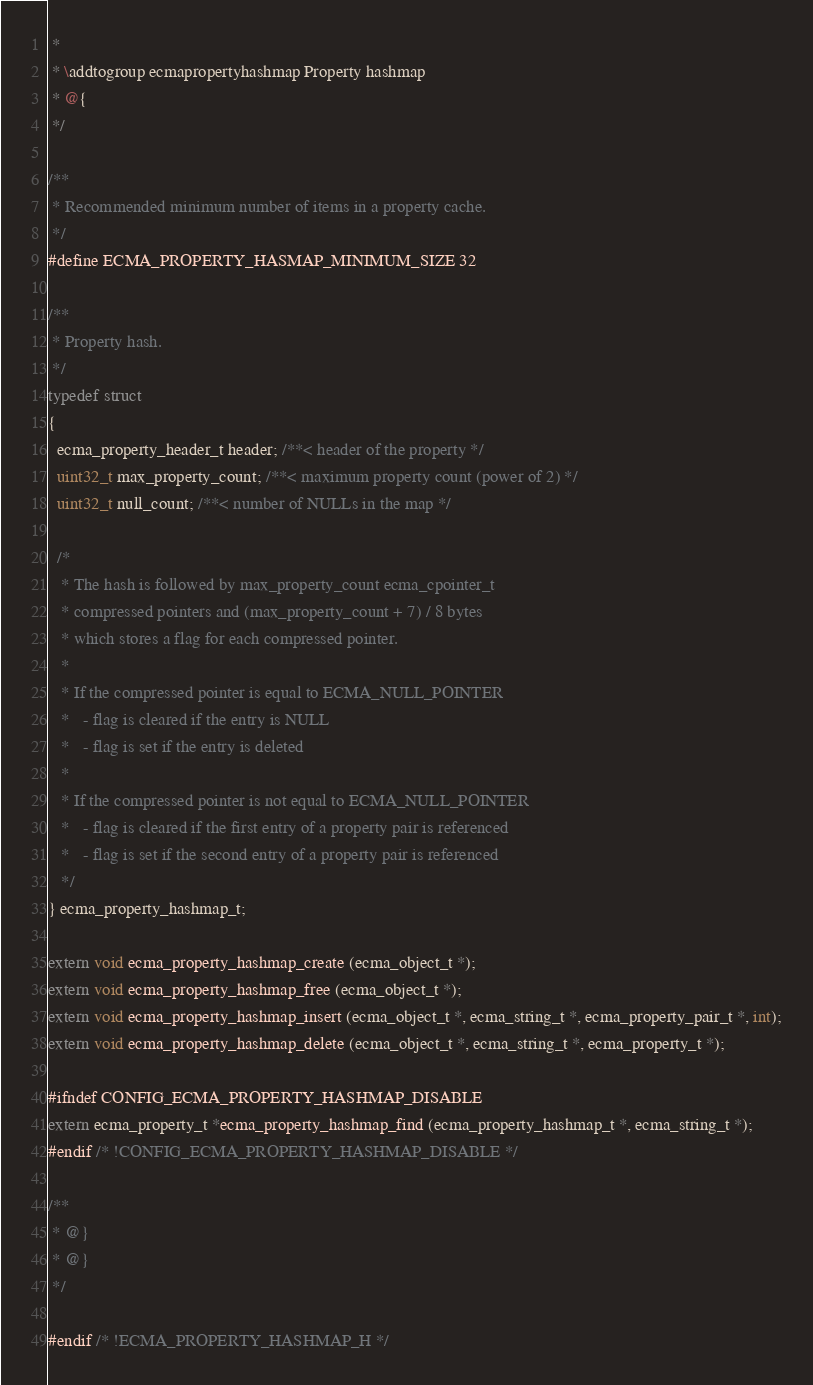<code> <loc_0><loc_0><loc_500><loc_500><_C_> *
 * \addtogroup ecmapropertyhashmap Property hashmap
 * @{
 */

/**
 * Recommended minimum number of items in a property cache.
 */
#define ECMA_PROPERTY_HASMAP_MINIMUM_SIZE 32

/**
 * Property hash.
 */
typedef struct
{
  ecma_property_header_t header; /**< header of the property */
  uint32_t max_property_count; /**< maximum property count (power of 2) */
  uint32_t null_count; /**< number of NULLs in the map */

  /*
   * The hash is followed by max_property_count ecma_cpointer_t
   * compressed pointers and (max_property_count + 7) / 8 bytes
   * which stores a flag for each compressed pointer.
   *
   * If the compressed pointer is equal to ECMA_NULL_POINTER
   *   - flag is cleared if the entry is NULL
   *   - flag is set if the entry is deleted
   *
   * If the compressed pointer is not equal to ECMA_NULL_POINTER
   *   - flag is cleared if the first entry of a property pair is referenced
   *   - flag is set if the second entry of a property pair is referenced
   */
} ecma_property_hashmap_t;

extern void ecma_property_hashmap_create (ecma_object_t *);
extern void ecma_property_hashmap_free (ecma_object_t *);
extern void ecma_property_hashmap_insert (ecma_object_t *, ecma_string_t *, ecma_property_pair_t *, int);
extern void ecma_property_hashmap_delete (ecma_object_t *, ecma_string_t *, ecma_property_t *);

#ifndef CONFIG_ECMA_PROPERTY_HASHMAP_DISABLE
extern ecma_property_t *ecma_property_hashmap_find (ecma_property_hashmap_t *, ecma_string_t *);
#endif /* !CONFIG_ECMA_PROPERTY_HASHMAP_DISABLE */

/**
 * @}
 * @}
 */

#endif /* !ECMA_PROPERTY_HASHMAP_H */
</code> 